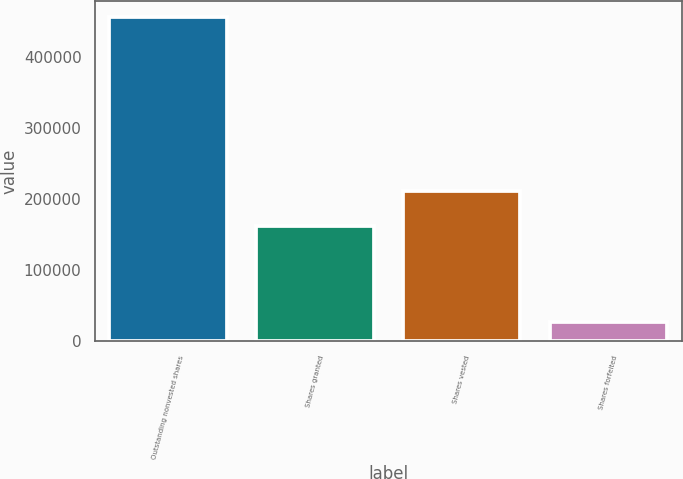Convert chart. <chart><loc_0><loc_0><loc_500><loc_500><bar_chart><fcel>Outstanding nonvested shares<fcel>Shares granted<fcel>Shares vested<fcel>Shares forfeited<nl><fcel>456282<fcel>161949<fcel>211907<fcel>27595<nl></chart> 